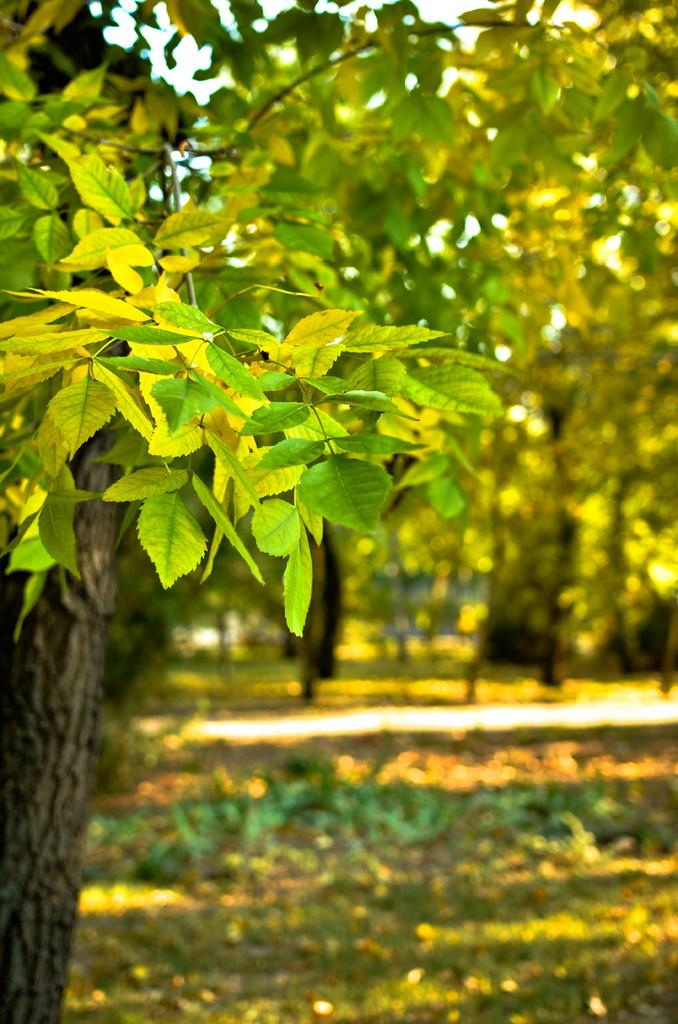What type of vegetation can be seen in the image? There are leaves, stems, and a tree trunk visible in the image. What can be seen in the background of the image? There are trees, plants, grass, and a walkway in the background of the image. How is the background of the image depicted? The background has a blurred view. How much sugar is present in the image? There is no sugar present in the image; it features vegetation and a blurred background. 